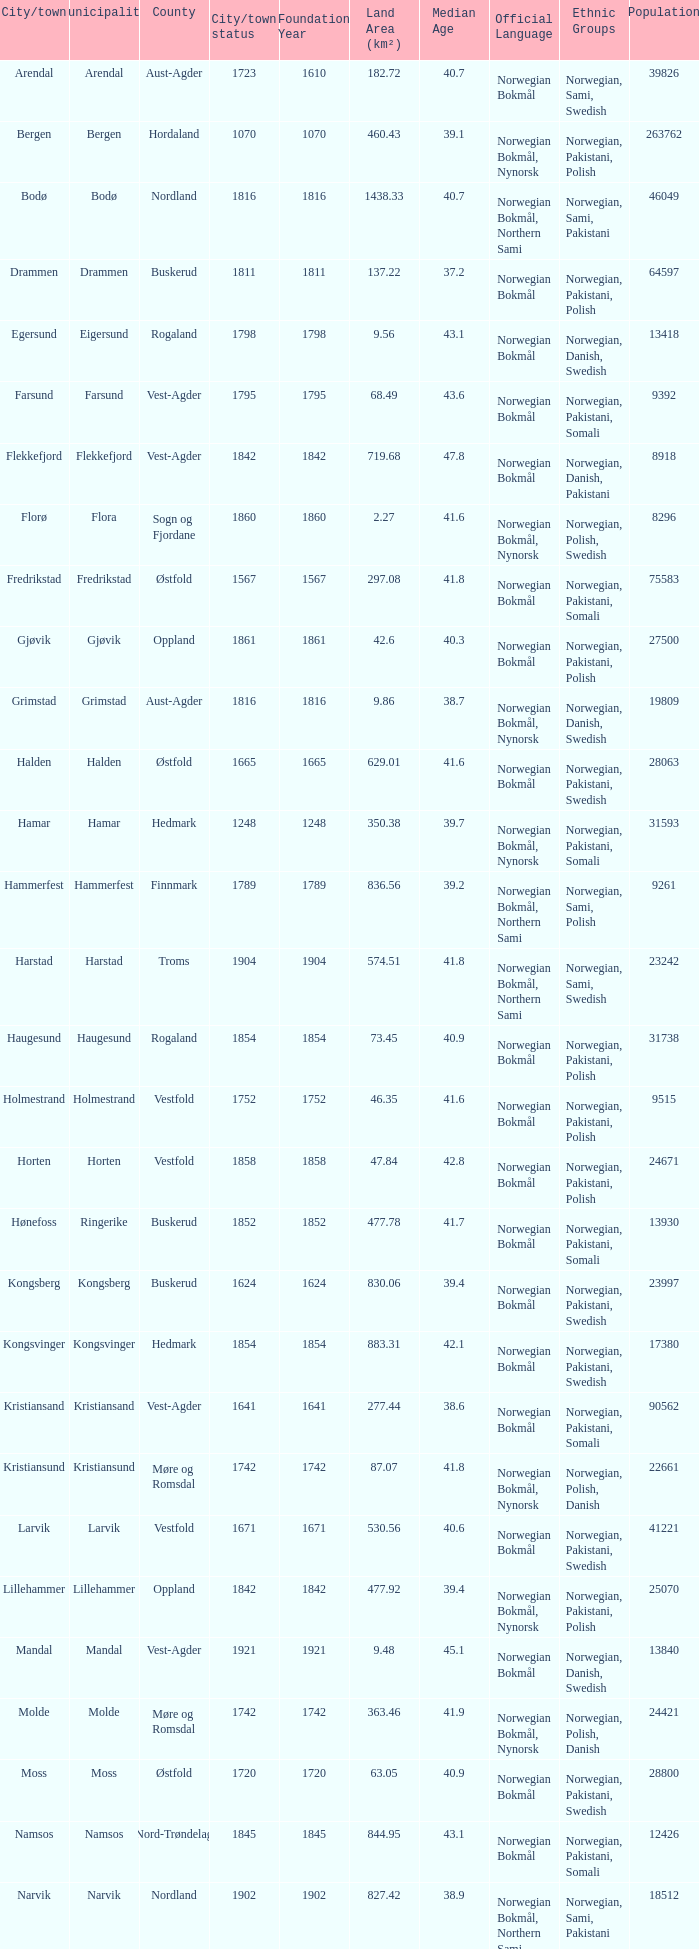Which municipalities located in the county of Finnmark have populations bigger than 6187.0? Hammerfest. 